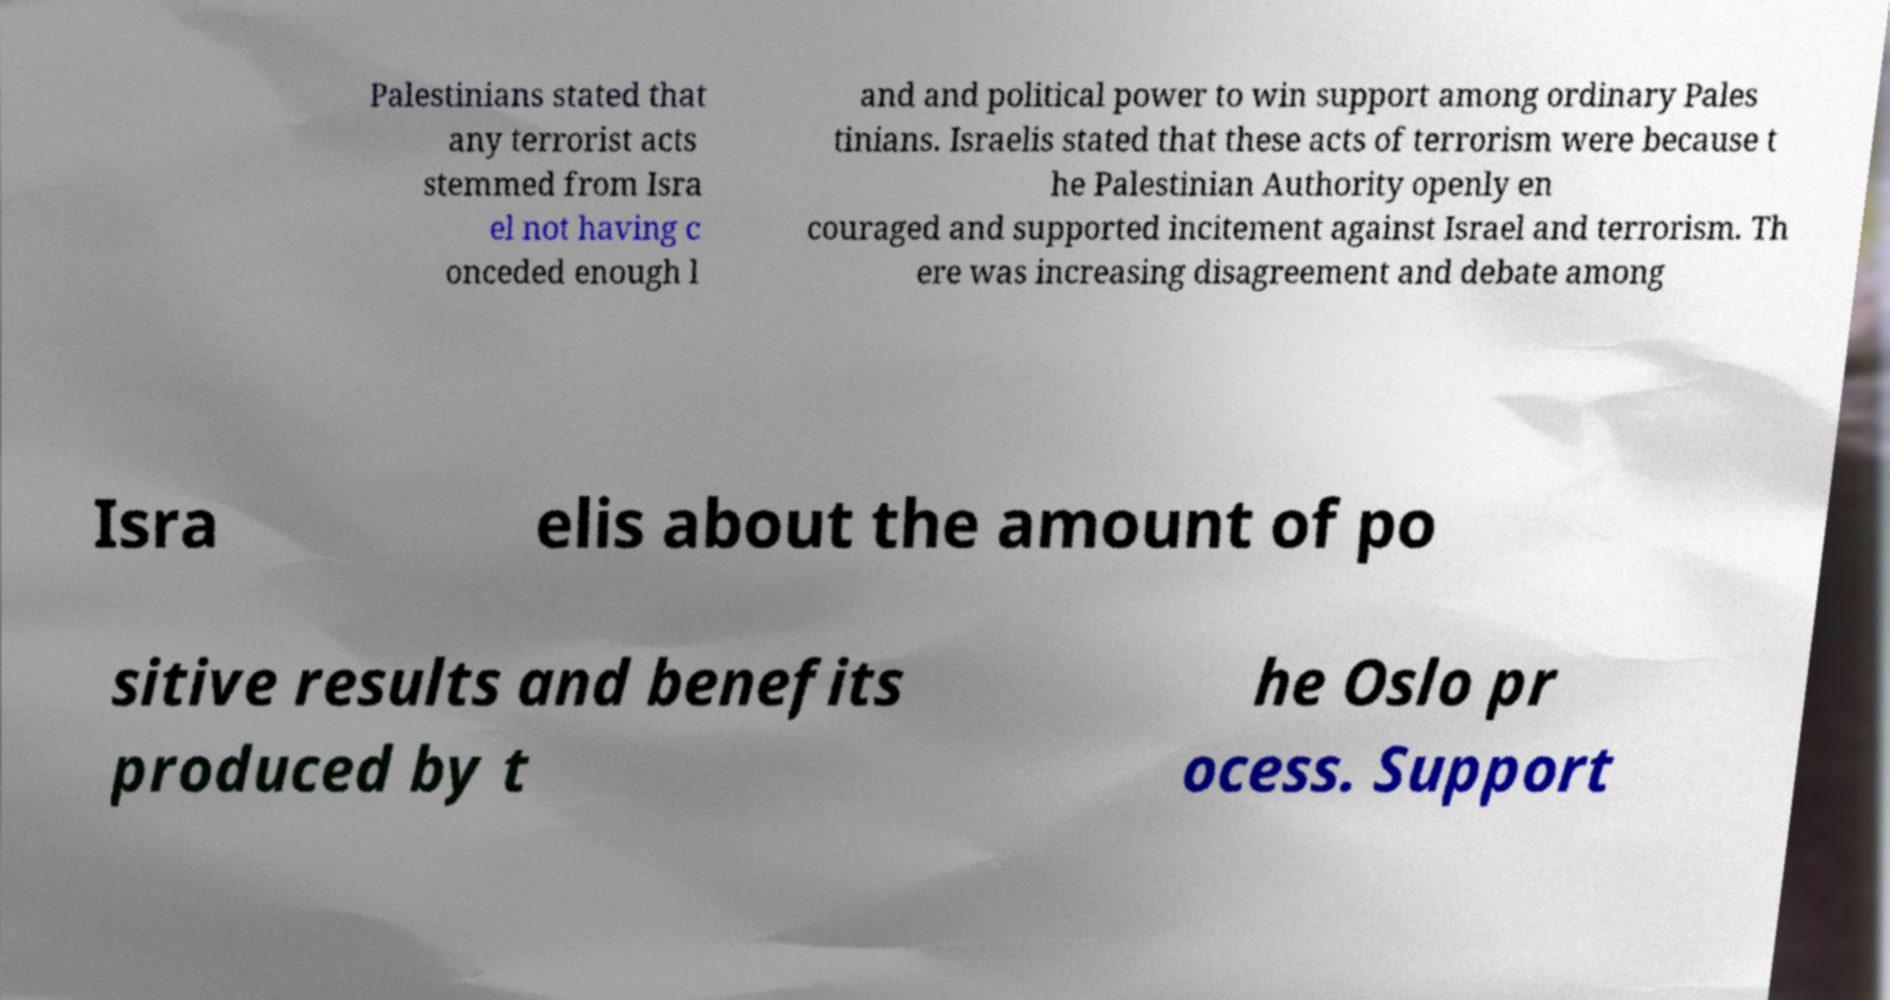Please identify and transcribe the text found in this image. Palestinians stated that any terrorist acts stemmed from Isra el not having c onceded enough l and and political power to win support among ordinary Pales tinians. Israelis stated that these acts of terrorism were because t he Palestinian Authority openly en couraged and supported incitement against Israel and terrorism. Th ere was increasing disagreement and debate among Isra elis about the amount of po sitive results and benefits produced by t he Oslo pr ocess. Support 